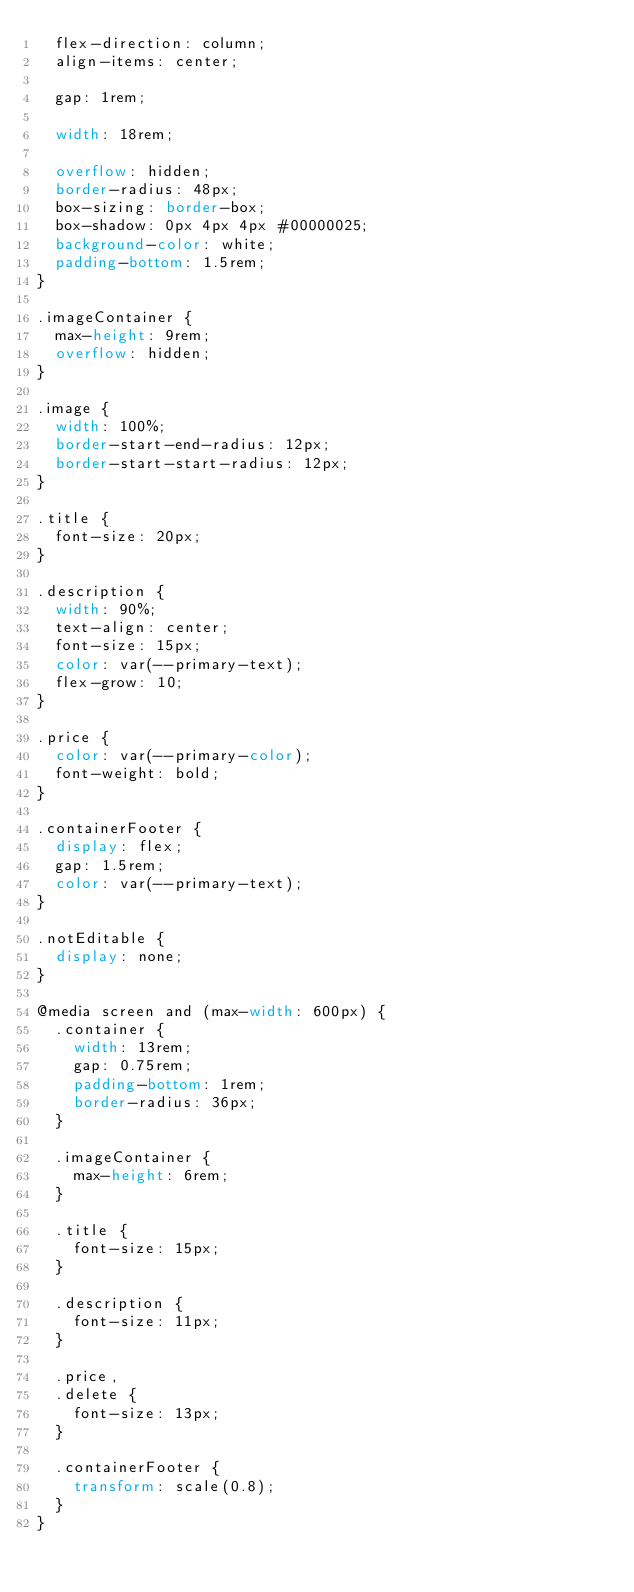<code> <loc_0><loc_0><loc_500><loc_500><_CSS_>  flex-direction: column;
  align-items: center;

  gap: 1rem;

  width: 18rem;

  overflow: hidden;
  border-radius: 48px;
  box-sizing: border-box;
  box-shadow: 0px 4px 4px #00000025;
  background-color: white;
  padding-bottom: 1.5rem;
}

.imageContainer {
  max-height: 9rem;
  overflow: hidden;
}

.image {
  width: 100%;
  border-start-end-radius: 12px;
  border-start-start-radius: 12px;
}

.title {
  font-size: 20px;
}

.description {
  width: 90%;
  text-align: center;
  font-size: 15px;
  color: var(--primary-text);
  flex-grow: 10;
}

.price {
  color: var(--primary-color);
  font-weight: bold;
}

.containerFooter {
  display: flex;
  gap: 1.5rem;
  color: var(--primary-text);
}

.notEditable {
  display: none;
}

@media screen and (max-width: 600px) {
  .container {
    width: 13rem;
    gap: 0.75rem;
    padding-bottom: 1rem;
    border-radius: 36px;
  }

  .imageContainer {
    max-height: 6rem;
  }

  .title {
    font-size: 15px;
  }

  .description {
    font-size: 11px;
  }

  .price,
  .delete {
    font-size: 13px;
  }

  .containerFooter {
    transform: scale(0.8);
  }
}
</code> 